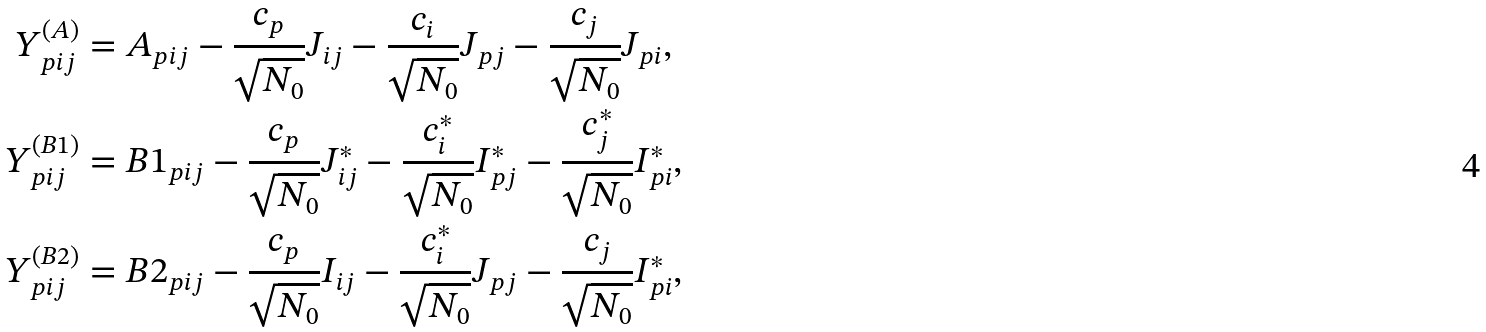<formula> <loc_0><loc_0><loc_500><loc_500>Y _ { p i j } ^ { ( A ) } & = A _ { p i j } - \frac { c _ { p } } { \sqrt { N _ { 0 } } } J _ { i j } - \frac { c _ { i } } { \sqrt { N _ { 0 } } } J _ { p j } - \frac { c _ { j } } { \sqrt { N _ { 0 } } } J _ { p i } , \\ Y _ { p i j } ^ { ( B 1 ) } & = B 1 _ { p i j } - \frac { c _ { p } } { \sqrt { N _ { 0 } } } J _ { i j } ^ { * } - \frac { c _ { i } ^ { * } } { \sqrt { N _ { 0 } } } I _ { p j } ^ { * } - \frac { c _ { j } ^ { * } } { \sqrt { N _ { 0 } } } I _ { p i } ^ { * } , \\ Y _ { p i j } ^ { ( B 2 ) } & = B 2 _ { p i j } - \frac { c _ { p } } { \sqrt { N _ { 0 } } } I _ { i j } - \frac { c _ { i } ^ { * } } { \sqrt { N _ { 0 } } } J _ { p j } - \frac { c _ { j } } { \sqrt { N _ { 0 } } } I _ { p i } ^ { * } ,</formula> 